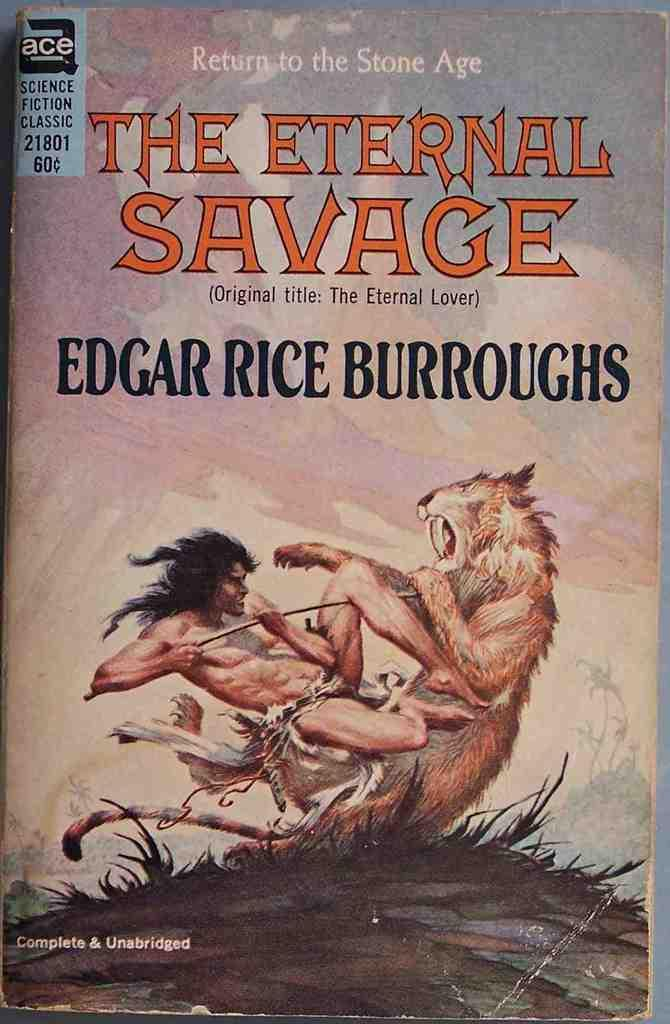<image>
Provide a brief description of the given image. A book cover with a man fighting a lion called The Eternal Savage. 